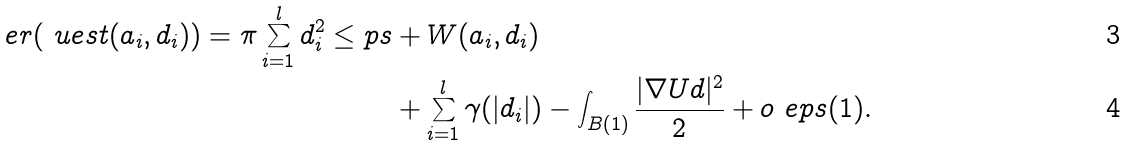<formula> <loc_0><loc_0><loc_500><loc_500>\ e r ( \ u e s t ( a _ { i } , d _ { i } ) ) = \pi \sum _ { i = 1 } ^ { l } d _ { i } ^ { 2 } \leq p s & + W ( a _ { i } , d _ { i } ) \\ & + \sum _ { i = 1 } ^ { l } \gamma ( | d _ { i } | ) - \int _ { B ( 1 ) } \frac { | \nabla U d | ^ { 2 } } { 2 } + o _ { \ } e p s ( 1 ) .</formula> 